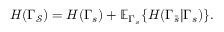Convert formula to latex. <formula><loc_0><loc_0><loc_500><loc_500>H ( \Gamma _ { \mathcal { S } } ) = H ( \Gamma _ { s } ) + \mathbb { E } _ { \Gamma _ { s } } \{ H ( \Gamma _ { \bar { s } } | \Gamma _ { s } ) \} .</formula> 